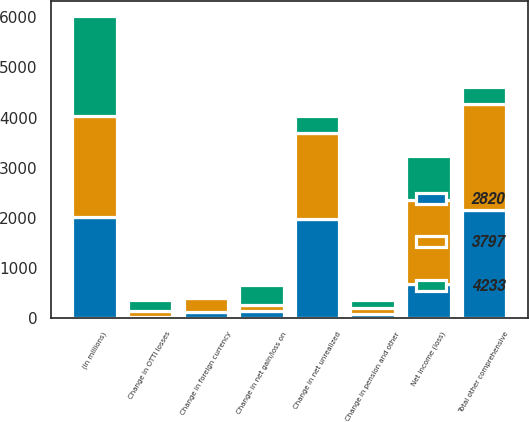Convert chart to OTSL. <chart><loc_0><loc_0><loc_500><loc_500><stacked_bar_chart><ecel><fcel>(In millions)<fcel>Net income (loss)<fcel>Change in net unrealized<fcel>Change in OTTI losses<fcel>Change in net gain/loss on<fcel>Change in foreign currency<fcel>Change in pension and other<fcel>Total other comprehensive<nl><fcel>2820<fcel>2011<fcel>662<fcel>1979<fcel>9<fcel>131<fcel>112<fcel>73<fcel>2158<nl><fcel>3797<fcel>2010<fcel>1680<fcel>1707<fcel>116<fcel>128<fcel>289<fcel>123<fcel>2117<nl><fcel>4233<fcel>2009<fcel>887<fcel>338<fcel>224<fcel>387<fcel>23<fcel>155<fcel>338<nl></chart> 